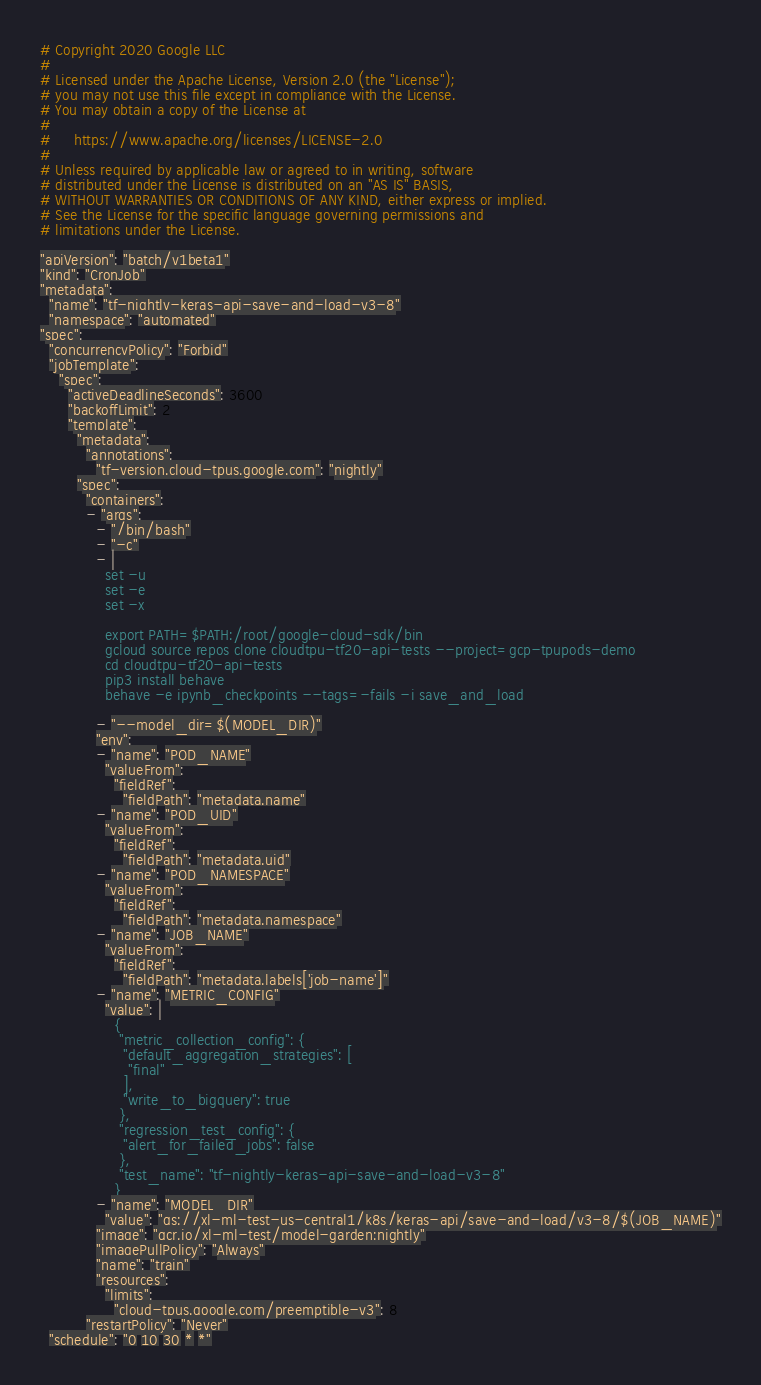<code> <loc_0><loc_0><loc_500><loc_500><_YAML_># Copyright 2020 Google LLC
#
# Licensed under the Apache License, Version 2.0 (the "License");
# you may not use this file except in compliance with the License.
# You may obtain a copy of the License at
#
#     https://www.apache.org/licenses/LICENSE-2.0
#
# Unless required by applicable law or agreed to in writing, software
# distributed under the License is distributed on an "AS IS" BASIS,
# WITHOUT WARRANTIES OR CONDITIONS OF ANY KIND, either express or implied.
# See the License for the specific language governing permissions and
# limitations under the License.

"apiVersion": "batch/v1beta1"
"kind": "CronJob"
"metadata":
  "name": "tf-nightly-keras-api-save-and-load-v3-8"
  "namespace": "automated"
"spec":
  "concurrencyPolicy": "Forbid"
  "jobTemplate":
    "spec":
      "activeDeadlineSeconds": 3600
      "backoffLimit": 2
      "template":
        "metadata":
          "annotations":
            "tf-version.cloud-tpus.google.com": "nightly"
        "spec":
          "containers":
          - "args":
            - "/bin/bash"
            - "-c"
            - |
              set -u
              set -e
              set -x
              
              export PATH=$PATH:/root/google-cloud-sdk/bin
              gcloud source repos clone cloudtpu-tf20-api-tests --project=gcp-tpupods-demo
              cd cloudtpu-tf20-api-tests
              pip3 install behave
              behave -e ipynb_checkpoints --tags=-fails -i save_and_load
              
            - "--model_dir=$(MODEL_DIR)"
            "env":
            - "name": "POD_NAME"
              "valueFrom":
                "fieldRef":
                  "fieldPath": "metadata.name"
            - "name": "POD_UID"
              "valueFrom":
                "fieldRef":
                  "fieldPath": "metadata.uid"
            - "name": "POD_NAMESPACE"
              "valueFrom":
                "fieldRef":
                  "fieldPath": "metadata.namespace"
            - "name": "JOB_NAME"
              "valueFrom":
                "fieldRef":
                  "fieldPath": "metadata.labels['job-name']"
            - "name": "METRIC_CONFIG"
              "value": |
                {
                 "metric_collection_config": {
                  "default_aggregation_strategies": [
                   "final"
                  ],
                  "write_to_bigquery": true
                 },
                 "regression_test_config": {
                  "alert_for_failed_jobs": false
                 },
                 "test_name": "tf-nightly-keras-api-save-and-load-v3-8"
                }
            - "name": "MODEL_DIR"
              "value": "gs://xl-ml-test-us-central1/k8s/keras-api/save-and-load/v3-8/$(JOB_NAME)"
            "image": "gcr.io/xl-ml-test/model-garden:nightly"
            "imagePullPolicy": "Always"
            "name": "train"
            "resources":
              "limits":
                "cloud-tpus.google.com/preemptible-v3": 8
          "restartPolicy": "Never"
  "schedule": "0 10 30 * *"</code> 